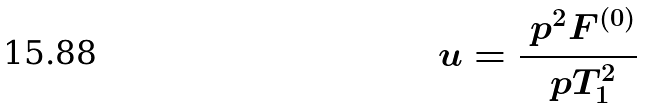Convert formula to latex. <formula><loc_0><loc_0><loc_500><loc_500>u = \frac { \ p ^ { 2 } { F ^ { ( 0 ) } } } { \ p T _ { 1 } ^ { 2 } }</formula> 